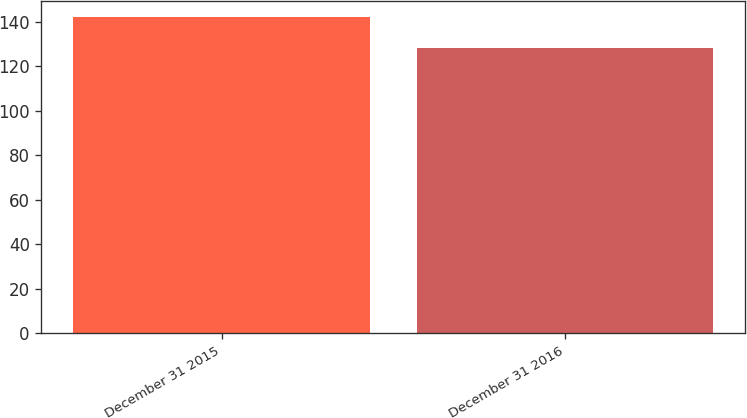Convert chart to OTSL. <chart><loc_0><loc_0><loc_500><loc_500><bar_chart><fcel>December 31 2015<fcel>December 31 2016<nl><fcel>142<fcel>128<nl></chart> 